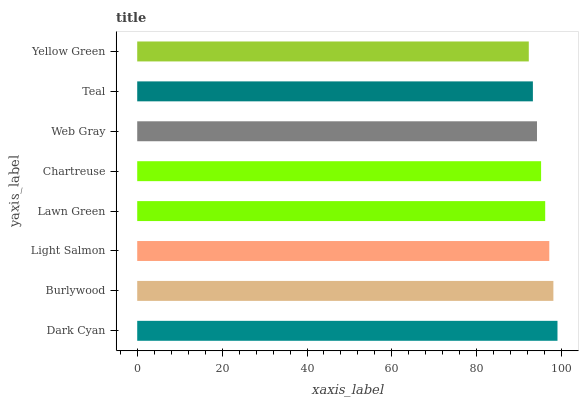Is Yellow Green the minimum?
Answer yes or no. Yes. Is Dark Cyan the maximum?
Answer yes or no. Yes. Is Burlywood the minimum?
Answer yes or no. No. Is Burlywood the maximum?
Answer yes or no. No. Is Dark Cyan greater than Burlywood?
Answer yes or no. Yes. Is Burlywood less than Dark Cyan?
Answer yes or no. Yes. Is Burlywood greater than Dark Cyan?
Answer yes or no. No. Is Dark Cyan less than Burlywood?
Answer yes or no. No. Is Lawn Green the high median?
Answer yes or no. Yes. Is Chartreuse the low median?
Answer yes or no. Yes. Is Teal the high median?
Answer yes or no. No. Is Light Salmon the low median?
Answer yes or no. No. 